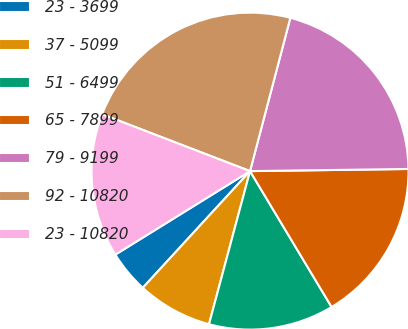Convert chart. <chart><loc_0><loc_0><loc_500><loc_500><pie_chart><fcel>23 - 3699<fcel>37 - 5099<fcel>51 - 6499<fcel>65 - 7899<fcel>79 - 9199<fcel>92 - 10820<fcel>23 - 10820<nl><fcel>4.34%<fcel>7.66%<fcel>12.77%<fcel>16.61%<fcel>20.69%<fcel>23.25%<fcel>14.67%<nl></chart> 